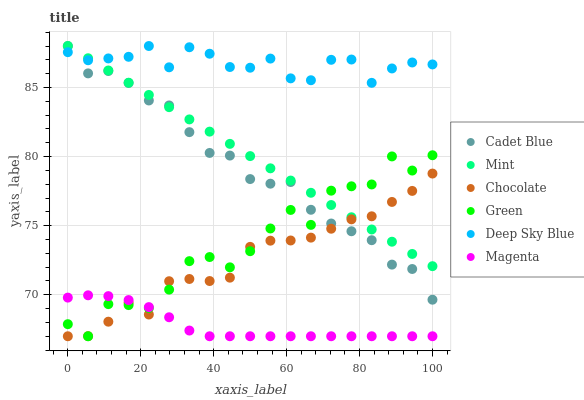Does Magenta have the minimum area under the curve?
Answer yes or no. Yes. Does Deep Sky Blue have the maximum area under the curve?
Answer yes or no. Yes. Does Chocolate have the minimum area under the curve?
Answer yes or no. No. Does Chocolate have the maximum area under the curve?
Answer yes or no. No. Is Mint the smoothest?
Answer yes or no. Yes. Is Green the roughest?
Answer yes or no. Yes. Is Chocolate the smoothest?
Answer yes or no. No. Is Chocolate the roughest?
Answer yes or no. No. Does Chocolate have the lowest value?
Answer yes or no. Yes. Does Deep Sky Blue have the lowest value?
Answer yes or no. No. Does Mint have the highest value?
Answer yes or no. Yes. Does Chocolate have the highest value?
Answer yes or no. No. Is Magenta less than Cadet Blue?
Answer yes or no. Yes. Is Deep Sky Blue greater than Chocolate?
Answer yes or no. Yes. Does Deep Sky Blue intersect Mint?
Answer yes or no. Yes. Is Deep Sky Blue less than Mint?
Answer yes or no. No. Is Deep Sky Blue greater than Mint?
Answer yes or no. No. Does Magenta intersect Cadet Blue?
Answer yes or no. No. 